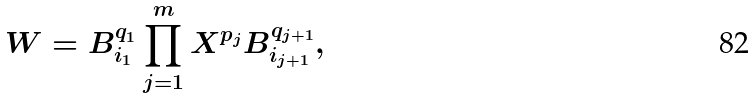<formula> <loc_0><loc_0><loc_500><loc_500>W = B _ { i _ { 1 } } ^ { q _ { 1 } } \prod _ { j = 1 } ^ { m } { X ^ { p _ { j } } B _ { i _ { j + 1 } } ^ { q _ { j + 1 } } } ,</formula> 